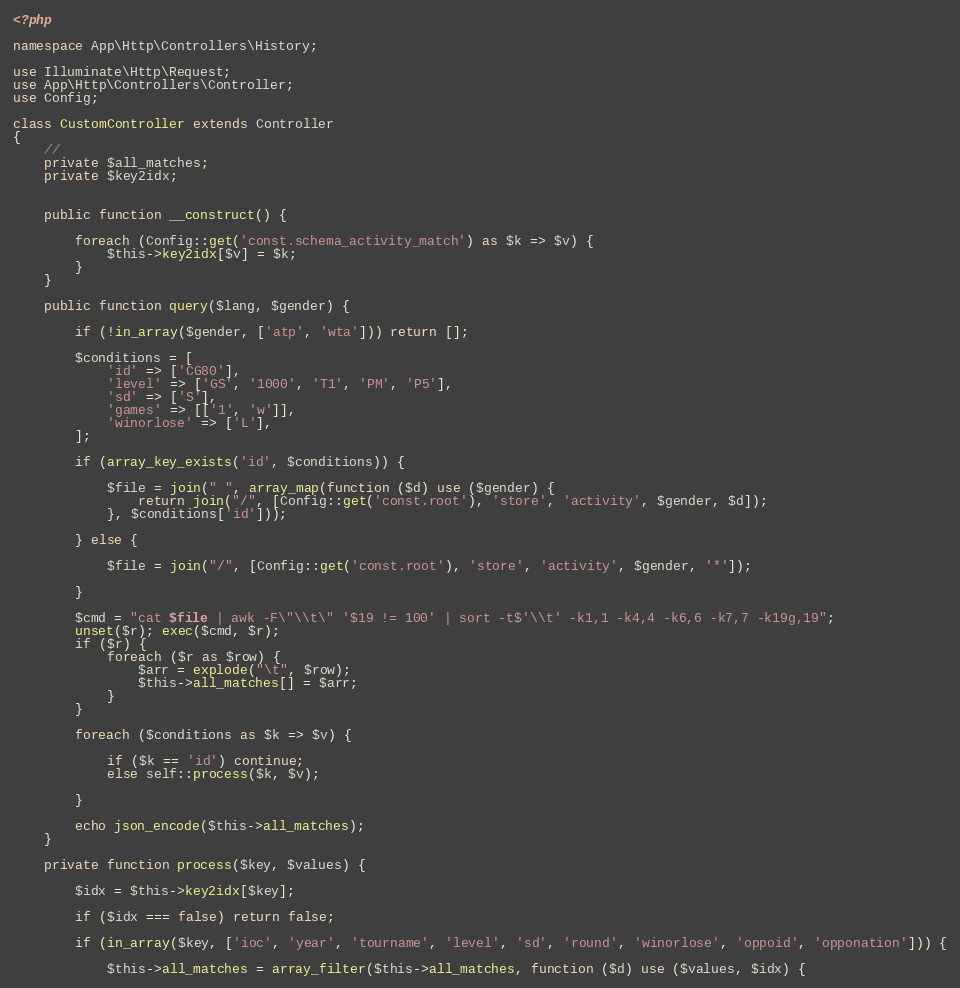<code> <loc_0><loc_0><loc_500><loc_500><_PHP_><?php

namespace App\Http\Controllers\History;

use Illuminate\Http\Request;
use App\Http\Controllers\Controller;
use Config;

class CustomController extends Controller
{
    //
	private $all_matches;
	private $key2idx;


	public function __construct() {
		
		foreach (Config::get('const.schema_activity_match') as $k => $v) {
			$this->key2idx[$v] = $k;
		}
	}

	public function query($lang, $gender) {

		if (!in_array($gender, ['atp', 'wta'])) return [];

		$conditions = [
			'id' => ['CG80'],
			'level' => ['GS', '1000', 'T1', 'PM', 'P5'],
			'sd' => ['S'],
			'games' => [['1', 'w']],
			'winorlose' => ['L'],
		];

		if (array_key_exists('id', $conditions)) {

			$file = join(" ", array_map(function ($d) use ($gender) {
				return join("/", [Config::get('const.root'), 'store', 'activity', $gender, $d]);
			}, $conditions['id']));

		} else {

			$file = join("/", [Config::get('const.root'), 'store', 'activity', $gender, '*']);

		}

		$cmd = "cat $file | awk -F\"\\t\" '$19 != 100' | sort -t$'\\t' -k1,1 -k4,4 -k6,6 -k7,7 -k19g,19";
		unset($r); exec($cmd, $r);
		if ($r) {
			foreach ($r as $row) {
				$arr = explode("\t", $row);
				$this->all_matches[] = $arr;
			}
		}

		foreach ($conditions as $k => $v) {

			if ($k == 'id') continue;
			else self::process($k, $v);

		}

		echo json_encode($this->all_matches);
	}

	private function process($key, $values) {

		$idx = $this->key2idx[$key];

		if ($idx === false) return false;

		if (in_array($key, ['ioc', 'year', 'tourname', 'level', 'sd', 'round', 'winorlose', 'oppoid', 'opponation'])) {

			$this->all_matches = array_filter($this->all_matches, function ($d) use ($values, $idx) {</code> 